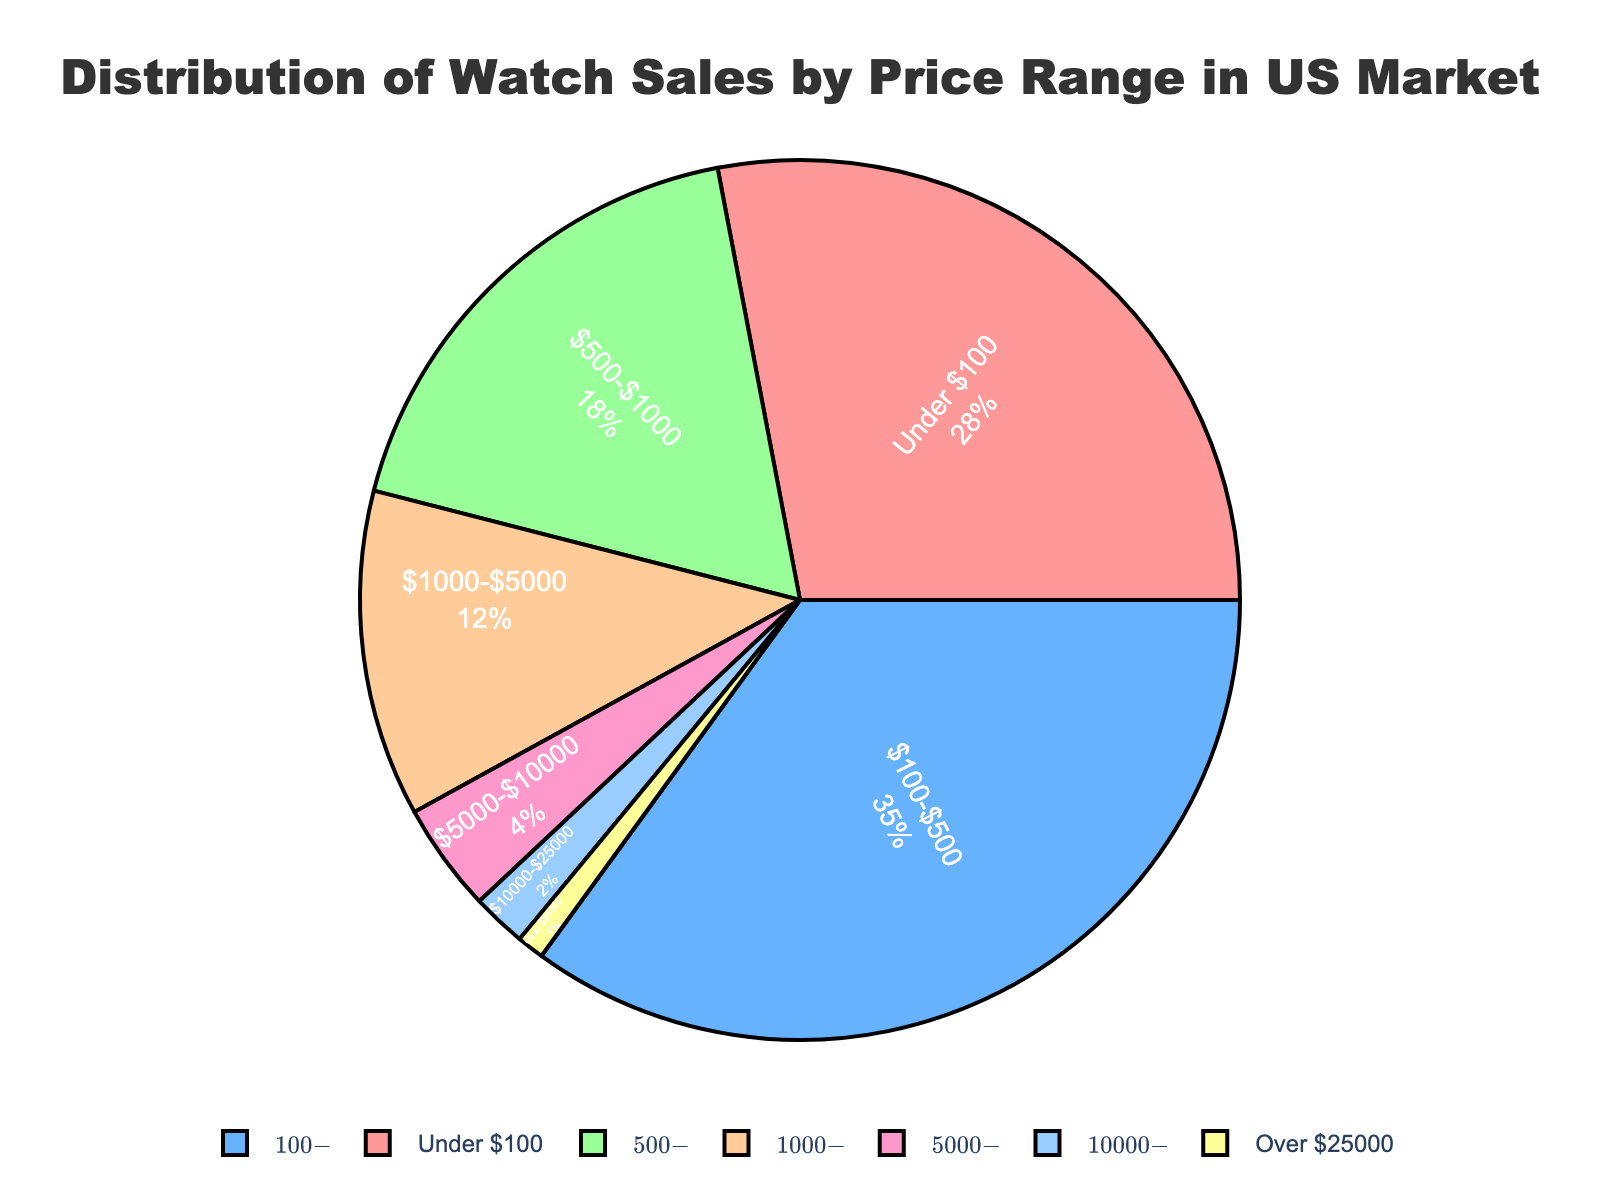What is the percentage of watch sales for price ranges under $500? Add the percentages for 'Under $100' and '$100-$500'. 'Under $100' is 28% and '$100-$500' is 35%. Summing these gives us 28% + 35% = 63%.
Answer: 63% Which price range has the highest percentage of watch sales? Observe the segments of the pie chart and identify the largest one. The '$100-$500' segment is the largest, with a percentage of 35%.
Answer: $100-$500 Is the proportion of watch sales for watches priced between $5000-$10000 higher or lower than those priced between $1000-$5000? Compare the segments for '$5000-$10000' and '$1000-$5000'. '$5000-$10000' is 4% and '$1000-$5000' is 12%. Therefore, 4% (5000-10000) is lower than 12% (1000-5000).
Answer: Lower What is the difference between the percentage of watch sales for the 'Under $100' and 'Over $25000' categories? Subtract the smaller percentage from the larger. 'Under $100' is 28% and 'Over $25000' is 1%. 28% - 1% = 27%.
Answer: 27% What percentage of watch sales comes from watches priced above $1000? Add the percentages for all categories above $1000: '$1000-$5000' (12%), '$5000-$10000' (4%), '$10000-$25000' (2%), and 'Over $25000' (1%). 12% + 4% + 2% + 1% = 19%.
Answer: 19% Which color represents the watch sales for the '$500-$1000' price range? Identify the color associated with the '$500-$1000' segment from the pie chart. The segment '$500-$1000' is represented by a green color.
Answer: Green Are there more watch sales for the 'Under $100' or '$500-$1000' price range? Compare the percentages of the two segments. 'Under $100' is 28%, and '$500-$1000' is 18%. Thus, 28% (Under $100) is more than 18% ($500-$1000).
Answer: Under $100 What is the combined percentage of watch sales for the '$5000-$10000' and '$10000-$25000' price ranges? Add the percentages of the two segments. '$5000-$10000' is 4%, and '$10000-$25000' is 2%. 4% + 2% = 6%.
Answer: 6% What is the percentage difference between watch sales in the '$100-$500' and '$500-$1000' categories? Subtract the smaller percentage from the larger one. '$100-$500' is 35% and '$500-$1000' is 18%. 35% - 18% = 17%.
Answer: 17% Which price range contributes less than 5% to the total watch sales? Look for segments with percentages less than 5%. The '$5000-$10000' (4%), '$10000-$25000' (2%), and 'Over $25000' (1%) segments all contribute less than 5%.
Answer: $5000-$10000, $10000-$25000, Over $25000 